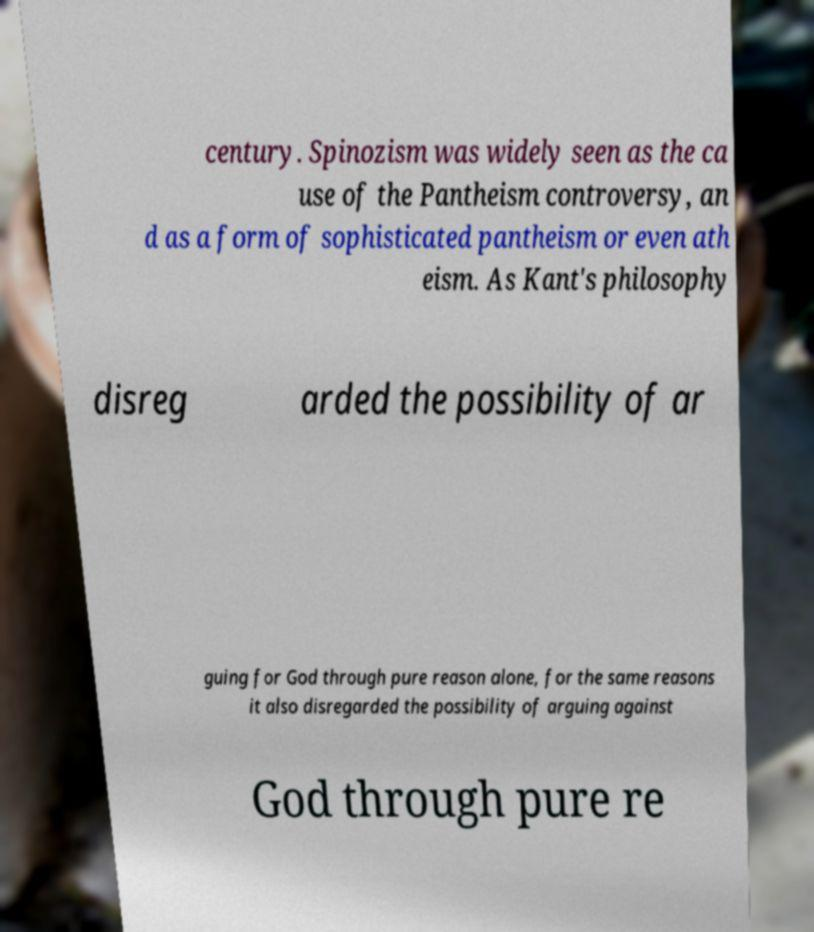For documentation purposes, I need the text within this image transcribed. Could you provide that? century. Spinozism was widely seen as the ca use of the Pantheism controversy, an d as a form of sophisticated pantheism or even ath eism. As Kant's philosophy disreg arded the possibility of ar guing for God through pure reason alone, for the same reasons it also disregarded the possibility of arguing against God through pure re 